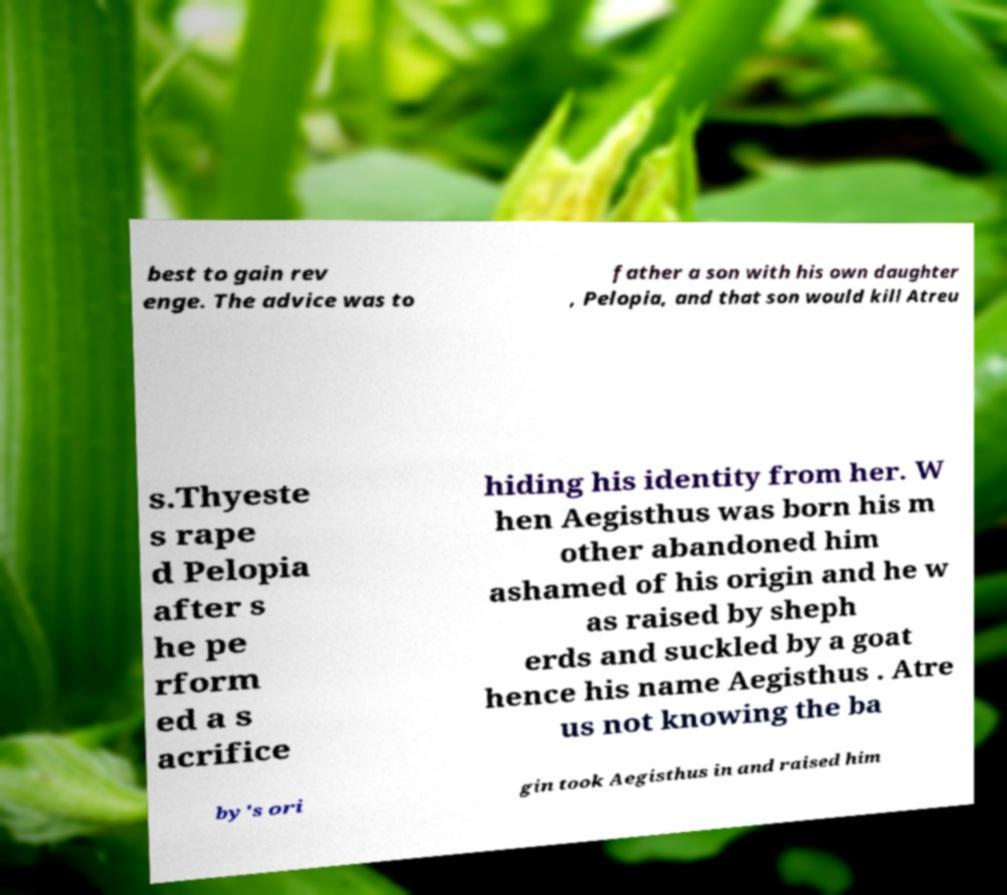For documentation purposes, I need the text within this image transcribed. Could you provide that? best to gain rev enge. The advice was to father a son with his own daughter , Pelopia, and that son would kill Atreu s.Thyeste s rape d Pelopia after s he pe rform ed a s acrifice hiding his identity from her. W hen Aegisthus was born his m other abandoned him ashamed of his origin and he w as raised by sheph erds and suckled by a goat hence his name Aegisthus . Atre us not knowing the ba by's ori gin took Aegisthus in and raised him 